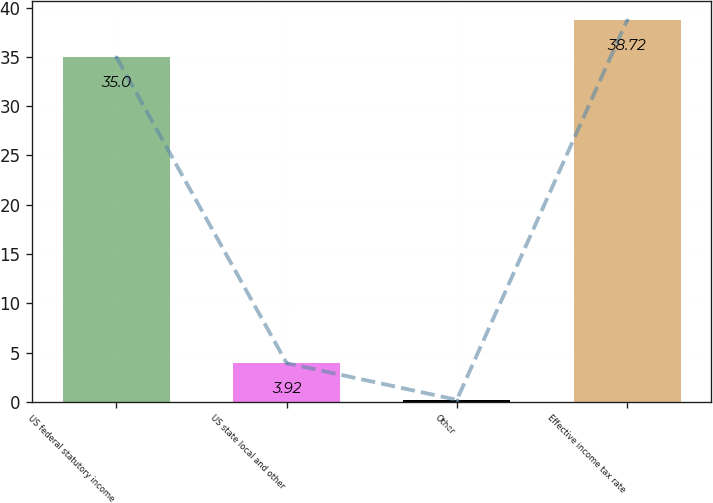Convert chart. <chart><loc_0><loc_0><loc_500><loc_500><bar_chart><fcel>US federal statutory income<fcel>US state local and other<fcel>Other<fcel>Effective income tax rate<nl><fcel>35<fcel>3.92<fcel>0.2<fcel>38.72<nl></chart> 